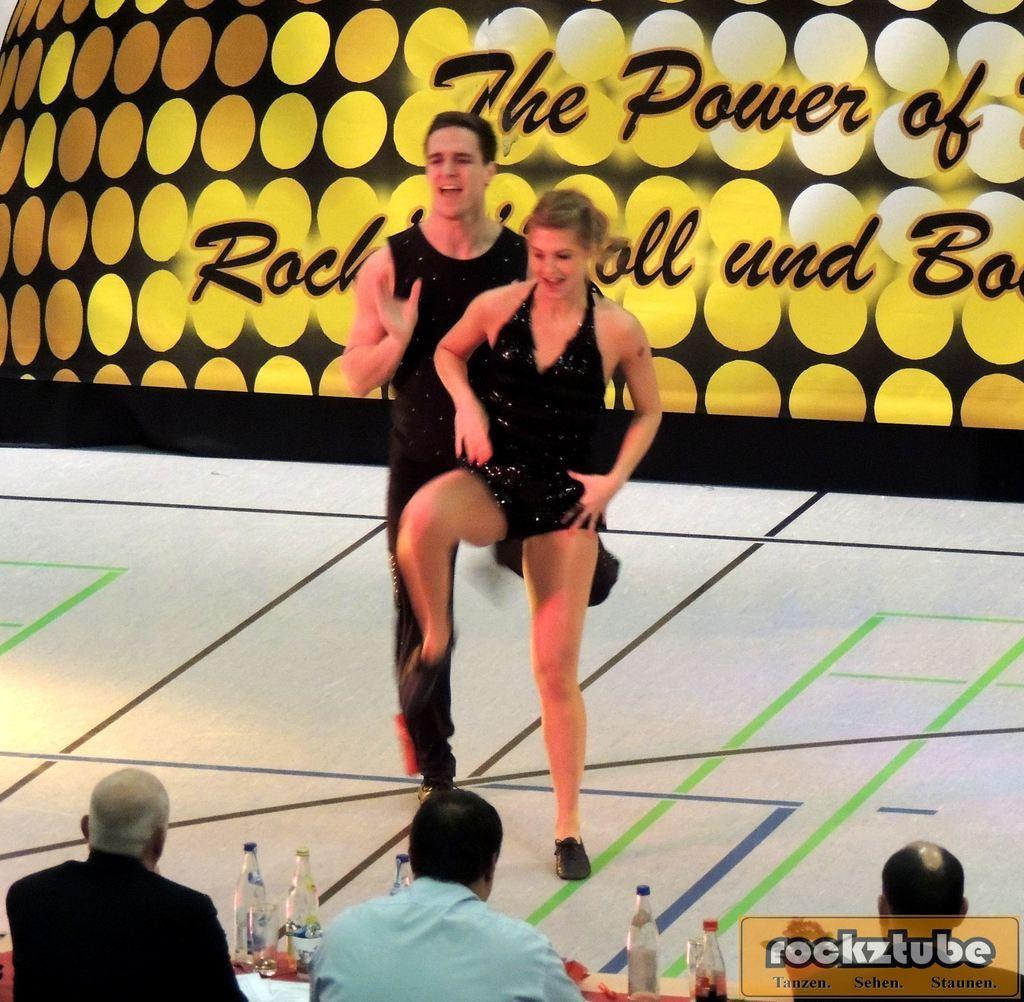Please provide a concise description of this image. In this image I can see a man and a woman are standing. I can also see three men in front of a table. On the table I can see bottles and other objects. In the background I can see some text. Here I can see some text on the image. 